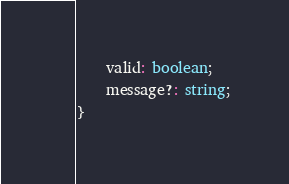<code> <loc_0><loc_0><loc_500><loc_500><_TypeScript_>    valid: boolean;
    message?: string;
}</code> 